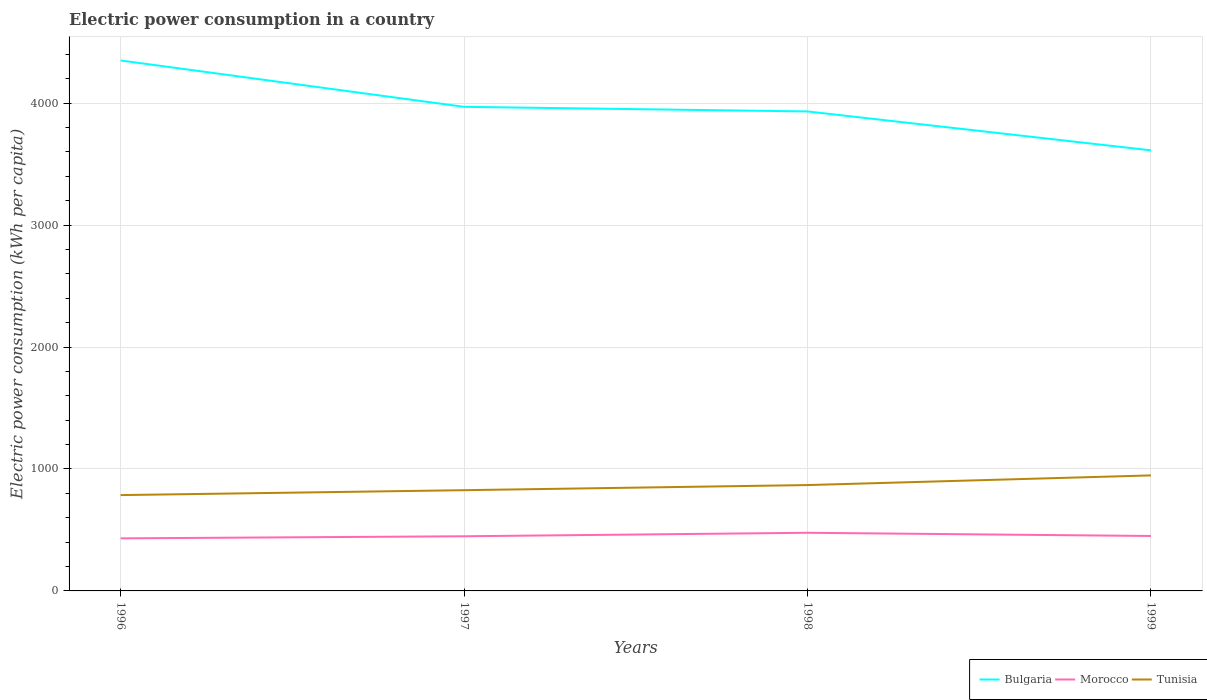How many different coloured lines are there?
Provide a succinct answer. 3. Does the line corresponding to Morocco intersect with the line corresponding to Bulgaria?
Ensure brevity in your answer.  No. Is the number of lines equal to the number of legend labels?
Your answer should be very brief. Yes. Across all years, what is the maximum electric power consumption in in Morocco?
Offer a very short reply. 431.07. What is the total electric power consumption in in Bulgaria in the graph?
Your response must be concise. 737.08. What is the difference between the highest and the second highest electric power consumption in in Morocco?
Give a very brief answer. 45.7. What is the difference between the highest and the lowest electric power consumption in in Morocco?
Give a very brief answer. 1. What is the difference between two consecutive major ticks on the Y-axis?
Offer a terse response. 1000. Where does the legend appear in the graph?
Offer a very short reply. Bottom right. How many legend labels are there?
Make the answer very short. 3. What is the title of the graph?
Your response must be concise. Electric power consumption in a country. Does "Guinea" appear as one of the legend labels in the graph?
Your answer should be compact. No. What is the label or title of the X-axis?
Give a very brief answer. Years. What is the label or title of the Y-axis?
Provide a short and direct response. Electric power consumption (kWh per capita). What is the Electric power consumption (kWh per capita) in Bulgaria in 1996?
Offer a very short reply. 4350.44. What is the Electric power consumption (kWh per capita) in Morocco in 1996?
Ensure brevity in your answer.  431.07. What is the Electric power consumption (kWh per capita) of Tunisia in 1996?
Provide a succinct answer. 785.98. What is the Electric power consumption (kWh per capita) in Bulgaria in 1997?
Your response must be concise. 3970.13. What is the Electric power consumption (kWh per capita) in Morocco in 1997?
Your answer should be compact. 448.27. What is the Electric power consumption (kWh per capita) of Tunisia in 1997?
Your answer should be compact. 826.16. What is the Electric power consumption (kWh per capita) in Bulgaria in 1998?
Your answer should be very brief. 3932.4. What is the Electric power consumption (kWh per capita) of Morocco in 1998?
Your answer should be compact. 476.77. What is the Electric power consumption (kWh per capita) in Tunisia in 1998?
Offer a terse response. 868.18. What is the Electric power consumption (kWh per capita) of Bulgaria in 1999?
Ensure brevity in your answer.  3613.37. What is the Electric power consumption (kWh per capita) of Morocco in 1999?
Offer a very short reply. 450.56. What is the Electric power consumption (kWh per capita) in Tunisia in 1999?
Provide a succinct answer. 947.45. Across all years, what is the maximum Electric power consumption (kWh per capita) of Bulgaria?
Give a very brief answer. 4350.44. Across all years, what is the maximum Electric power consumption (kWh per capita) of Morocco?
Offer a very short reply. 476.77. Across all years, what is the maximum Electric power consumption (kWh per capita) of Tunisia?
Offer a terse response. 947.45. Across all years, what is the minimum Electric power consumption (kWh per capita) of Bulgaria?
Your response must be concise. 3613.37. Across all years, what is the minimum Electric power consumption (kWh per capita) in Morocco?
Give a very brief answer. 431.07. Across all years, what is the minimum Electric power consumption (kWh per capita) in Tunisia?
Your response must be concise. 785.98. What is the total Electric power consumption (kWh per capita) in Bulgaria in the graph?
Provide a short and direct response. 1.59e+04. What is the total Electric power consumption (kWh per capita) of Morocco in the graph?
Keep it short and to the point. 1806.68. What is the total Electric power consumption (kWh per capita) in Tunisia in the graph?
Keep it short and to the point. 3427.77. What is the difference between the Electric power consumption (kWh per capita) in Bulgaria in 1996 and that in 1997?
Offer a terse response. 380.31. What is the difference between the Electric power consumption (kWh per capita) in Morocco in 1996 and that in 1997?
Your answer should be compact. -17.2. What is the difference between the Electric power consumption (kWh per capita) in Tunisia in 1996 and that in 1997?
Offer a terse response. -40.18. What is the difference between the Electric power consumption (kWh per capita) of Bulgaria in 1996 and that in 1998?
Offer a very short reply. 418.04. What is the difference between the Electric power consumption (kWh per capita) of Morocco in 1996 and that in 1998?
Your answer should be very brief. -45.7. What is the difference between the Electric power consumption (kWh per capita) of Tunisia in 1996 and that in 1998?
Keep it short and to the point. -82.2. What is the difference between the Electric power consumption (kWh per capita) of Bulgaria in 1996 and that in 1999?
Your response must be concise. 737.08. What is the difference between the Electric power consumption (kWh per capita) in Morocco in 1996 and that in 1999?
Provide a short and direct response. -19.49. What is the difference between the Electric power consumption (kWh per capita) of Tunisia in 1996 and that in 1999?
Your answer should be very brief. -161.47. What is the difference between the Electric power consumption (kWh per capita) in Bulgaria in 1997 and that in 1998?
Offer a very short reply. 37.73. What is the difference between the Electric power consumption (kWh per capita) of Morocco in 1997 and that in 1998?
Provide a succinct answer. -28.5. What is the difference between the Electric power consumption (kWh per capita) of Tunisia in 1997 and that in 1998?
Your response must be concise. -42.02. What is the difference between the Electric power consumption (kWh per capita) in Bulgaria in 1997 and that in 1999?
Your response must be concise. 356.76. What is the difference between the Electric power consumption (kWh per capita) of Morocco in 1997 and that in 1999?
Provide a short and direct response. -2.29. What is the difference between the Electric power consumption (kWh per capita) of Tunisia in 1997 and that in 1999?
Your response must be concise. -121.29. What is the difference between the Electric power consumption (kWh per capita) in Bulgaria in 1998 and that in 1999?
Your response must be concise. 319.03. What is the difference between the Electric power consumption (kWh per capita) of Morocco in 1998 and that in 1999?
Your answer should be very brief. 26.21. What is the difference between the Electric power consumption (kWh per capita) of Tunisia in 1998 and that in 1999?
Your response must be concise. -79.27. What is the difference between the Electric power consumption (kWh per capita) of Bulgaria in 1996 and the Electric power consumption (kWh per capita) of Morocco in 1997?
Give a very brief answer. 3902.17. What is the difference between the Electric power consumption (kWh per capita) of Bulgaria in 1996 and the Electric power consumption (kWh per capita) of Tunisia in 1997?
Offer a very short reply. 3524.28. What is the difference between the Electric power consumption (kWh per capita) in Morocco in 1996 and the Electric power consumption (kWh per capita) in Tunisia in 1997?
Your answer should be compact. -395.09. What is the difference between the Electric power consumption (kWh per capita) of Bulgaria in 1996 and the Electric power consumption (kWh per capita) of Morocco in 1998?
Keep it short and to the point. 3873.67. What is the difference between the Electric power consumption (kWh per capita) of Bulgaria in 1996 and the Electric power consumption (kWh per capita) of Tunisia in 1998?
Offer a terse response. 3482.26. What is the difference between the Electric power consumption (kWh per capita) of Morocco in 1996 and the Electric power consumption (kWh per capita) of Tunisia in 1998?
Offer a terse response. -437.11. What is the difference between the Electric power consumption (kWh per capita) of Bulgaria in 1996 and the Electric power consumption (kWh per capita) of Morocco in 1999?
Ensure brevity in your answer.  3899.88. What is the difference between the Electric power consumption (kWh per capita) of Bulgaria in 1996 and the Electric power consumption (kWh per capita) of Tunisia in 1999?
Give a very brief answer. 3402.99. What is the difference between the Electric power consumption (kWh per capita) in Morocco in 1996 and the Electric power consumption (kWh per capita) in Tunisia in 1999?
Offer a very short reply. -516.38. What is the difference between the Electric power consumption (kWh per capita) in Bulgaria in 1997 and the Electric power consumption (kWh per capita) in Morocco in 1998?
Offer a very short reply. 3493.36. What is the difference between the Electric power consumption (kWh per capita) of Bulgaria in 1997 and the Electric power consumption (kWh per capita) of Tunisia in 1998?
Offer a very short reply. 3101.95. What is the difference between the Electric power consumption (kWh per capita) of Morocco in 1997 and the Electric power consumption (kWh per capita) of Tunisia in 1998?
Provide a succinct answer. -419.91. What is the difference between the Electric power consumption (kWh per capita) of Bulgaria in 1997 and the Electric power consumption (kWh per capita) of Morocco in 1999?
Keep it short and to the point. 3519.57. What is the difference between the Electric power consumption (kWh per capita) of Bulgaria in 1997 and the Electric power consumption (kWh per capita) of Tunisia in 1999?
Keep it short and to the point. 3022.68. What is the difference between the Electric power consumption (kWh per capita) in Morocco in 1997 and the Electric power consumption (kWh per capita) in Tunisia in 1999?
Keep it short and to the point. -499.18. What is the difference between the Electric power consumption (kWh per capita) in Bulgaria in 1998 and the Electric power consumption (kWh per capita) in Morocco in 1999?
Give a very brief answer. 3481.84. What is the difference between the Electric power consumption (kWh per capita) in Bulgaria in 1998 and the Electric power consumption (kWh per capita) in Tunisia in 1999?
Ensure brevity in your answer.  2984.95. What is the difference between the Electric power consumption (kWh per capita) of Morocco in 1998 and the Electric power consumption (kWh per capita) of Tunisia in 1999?
Provide a succinct answer. -470.68. What is the average Electric power consumption (kWh per capita) in Bulgaria per year?
Ensure brevity in your answer.  3966.59. What is the average Electric power consumption (kWh per capita) in Morocco per year?
Provide a succinct answer. 451.67. What is the average Electric power consumption (kWh per capita) of Tunisia per year?
Your answer should be compact. 856.94. In the year 1996, what is the difference between the Electric power consumption (kWh per capita) in Bulgaria and Electric power consumption (kWh per capita) in Morocco?
Give a very brief answer. 3919.37. In the year 1996, what is the difference between the Electric power consumption (kWh per capita) in Bulgaria and Electric power consumption (kWh per capita) in Tunisia?
Your answer should be very brief. 3564.46. In the year 1996, what is the difference between the Electric power consumption (kWh per capita) of Morocco and Electric power consumption (kWh per capita) of Tunisia?
Your answer should be very brief. -354.91. In the year 1997, what is the difference between the Electric power consumption (kWh per capita) in Bulgaria and Electric power consumption (kWh per capita) in Morocco?
Provide a short and direct response. 3521.86. In the year 1997, what is the difference between the Electric power consumption (kWh per capita) of Bulgaria and Electric power consumption (kWh per capita) of Tunisia?
Ensure brevity in your answer.  3143.97. In the year 1997, what is the difference between the Electric power consumption (kWh per capita) in Morocco and Electric power consumption (kWh per capita) in Tunisia?
Provide a short and direct response. -377.89. In the year 1998, what is the difference between the Electric power consumption (kWh per capita) of Bulgaria and Electric power consumption (kWh per capita) of Morocco?
Your answer should be compact. 3455.63. In the year 1998, what is the difference between the Electric power consumption (kWh per capita) of Bulgaria and Electric power consumption (kWh per capita) of Tunisia?
Provide a short and direct response. 3064.22. In the year 1998, what is the difference between the Electric power consumption (kWh per capita) of Morocco and Electric power consumption (kWh per capita) of Tunisia?
Make the answer very short. -391.41. In the year 1999, what is the difference between the Electric power consumption (kWh per capita) in Bulgaria and Electric power consumption (kWh per capita) in Morocco?
Keep it short and to the point. 3162.81. In the year 1999, what is the difference between the Electric power consumption (kWh per capita) in Bulgaria and Electric power consumption (kWh per capita) in Tunisia?
Your response must be concise. 2665.92. In the year 1999, what is the difference between the Electric power consumption (kWh per capita) of Morocco and Electric power consumption (kWh per capita) of Tunisia?
Make the answer very short. -496.89. What is the ratio of the Electric power consumption (kWh per capita) in Bulgaria in 1996 to that in 1997?
Keep it short and to the point. 1.1. What is the ratio of the Electric power consumption (kWh per capita) of Morocco in 1996 to that in 1997?
Ensure brevity in your answer.  0.96. What is the ratio of the Electric power consumption (kWh per capita) of Tunisia in 1996 to that in 1997?
Provide a succinct answer. 0.95. What is the ratio of the Electric power consumption (kWh per capita) in Bulgaria in 1996 to that in 1998?
Your response must be concise. 1.11. What is the ratio of the Electric power consumption (kWh per capita) of Morocco in 1996 to that in 1998?
Your answer should be compact. 0.9. What is the ratio of the Electric power consumption (kWh per capita) of Tunisia in 1996 to that in 1998?
Keep it short and to the point. 0.91. What is the ratio of the Electric power consumption (kWh per capita) in Bulgaria in 1996 to that in 1999?
Offer a terse response. 1.2. What is the ratio of the Electric power consumption (kWh per capita) in Morocco in 1996 to that in 1999?
Keep it short and to the point. 0.96. What is the ratio of the Electric power consumption (kWh per capita) in Tunisia in 1996 to that in 1999?
Provide a succinct answer. 0.83. What is the ratio of the Electric power consumption (kWh per capita) of Bulgaria in 1997 to that in 1998?
Ensure brevity in your answer.  1.01. What is the ratio of the Electric power consumption (kWh per capita) in Morocco in 1997 to that in 1998?
Offer a terse response. 0.94. What is the ratio of the Electric power consumption (kWh per capita) of Tunisia in 1997 to that in 1998?
Make the answer very short. 0.95. What is the ratio of the Electric power consumption (kWh per capita) of Bulgaria in 1997 to that in 1999?
Provide a succinct answer. 1.1. What is the ratio of the Electric power consumption (kWh per capita) of Tunisia in 1997 to that in 1999?
Your answer should be very brief. 0.87. What is the ratio of the Electric power consumption (kWh per capita) in Bulgaria in 1998 to that in 1999?
Your answer should be compact. 1.09. What is the ratio of the Electric power consumption (kWh per capita) in Morocco in 1998 to that in 1999?
Make the answer very short. 1.06. What is the ratio of the Electric power consumption (kWh per capita) in Tunisia in 1998 to that in 1999?
Make the answer very short. 0.92. What is the difference between the highest and the second highest Electric power consumption (kWh per capita) in Bulgaria?
Make the answer very short. 380.31. What is the difference between the highest and the second highest Electric power consumption (kWh per capita) in Morocco?
Make the answer very short. 26.21. What is the difference between the highest and the second highest Electric power consumption (kWh per capita) of Tunisia?
Give a very brief answer. 79.27. What is the difference between the highest and the lowest Electric power consumption (kWh per capita) in Bulgaria?
Offer a very short reply. 737.08. What is the difference between the highest and the lowest Electric power consumption (kWh per capita) of Morocco?
Your response must be concise. 45.7. What is the difference between the highest and the lowest Electric power consumption (kWh per capita) of Tunisia?
Give a very brief answer. 161.47. 